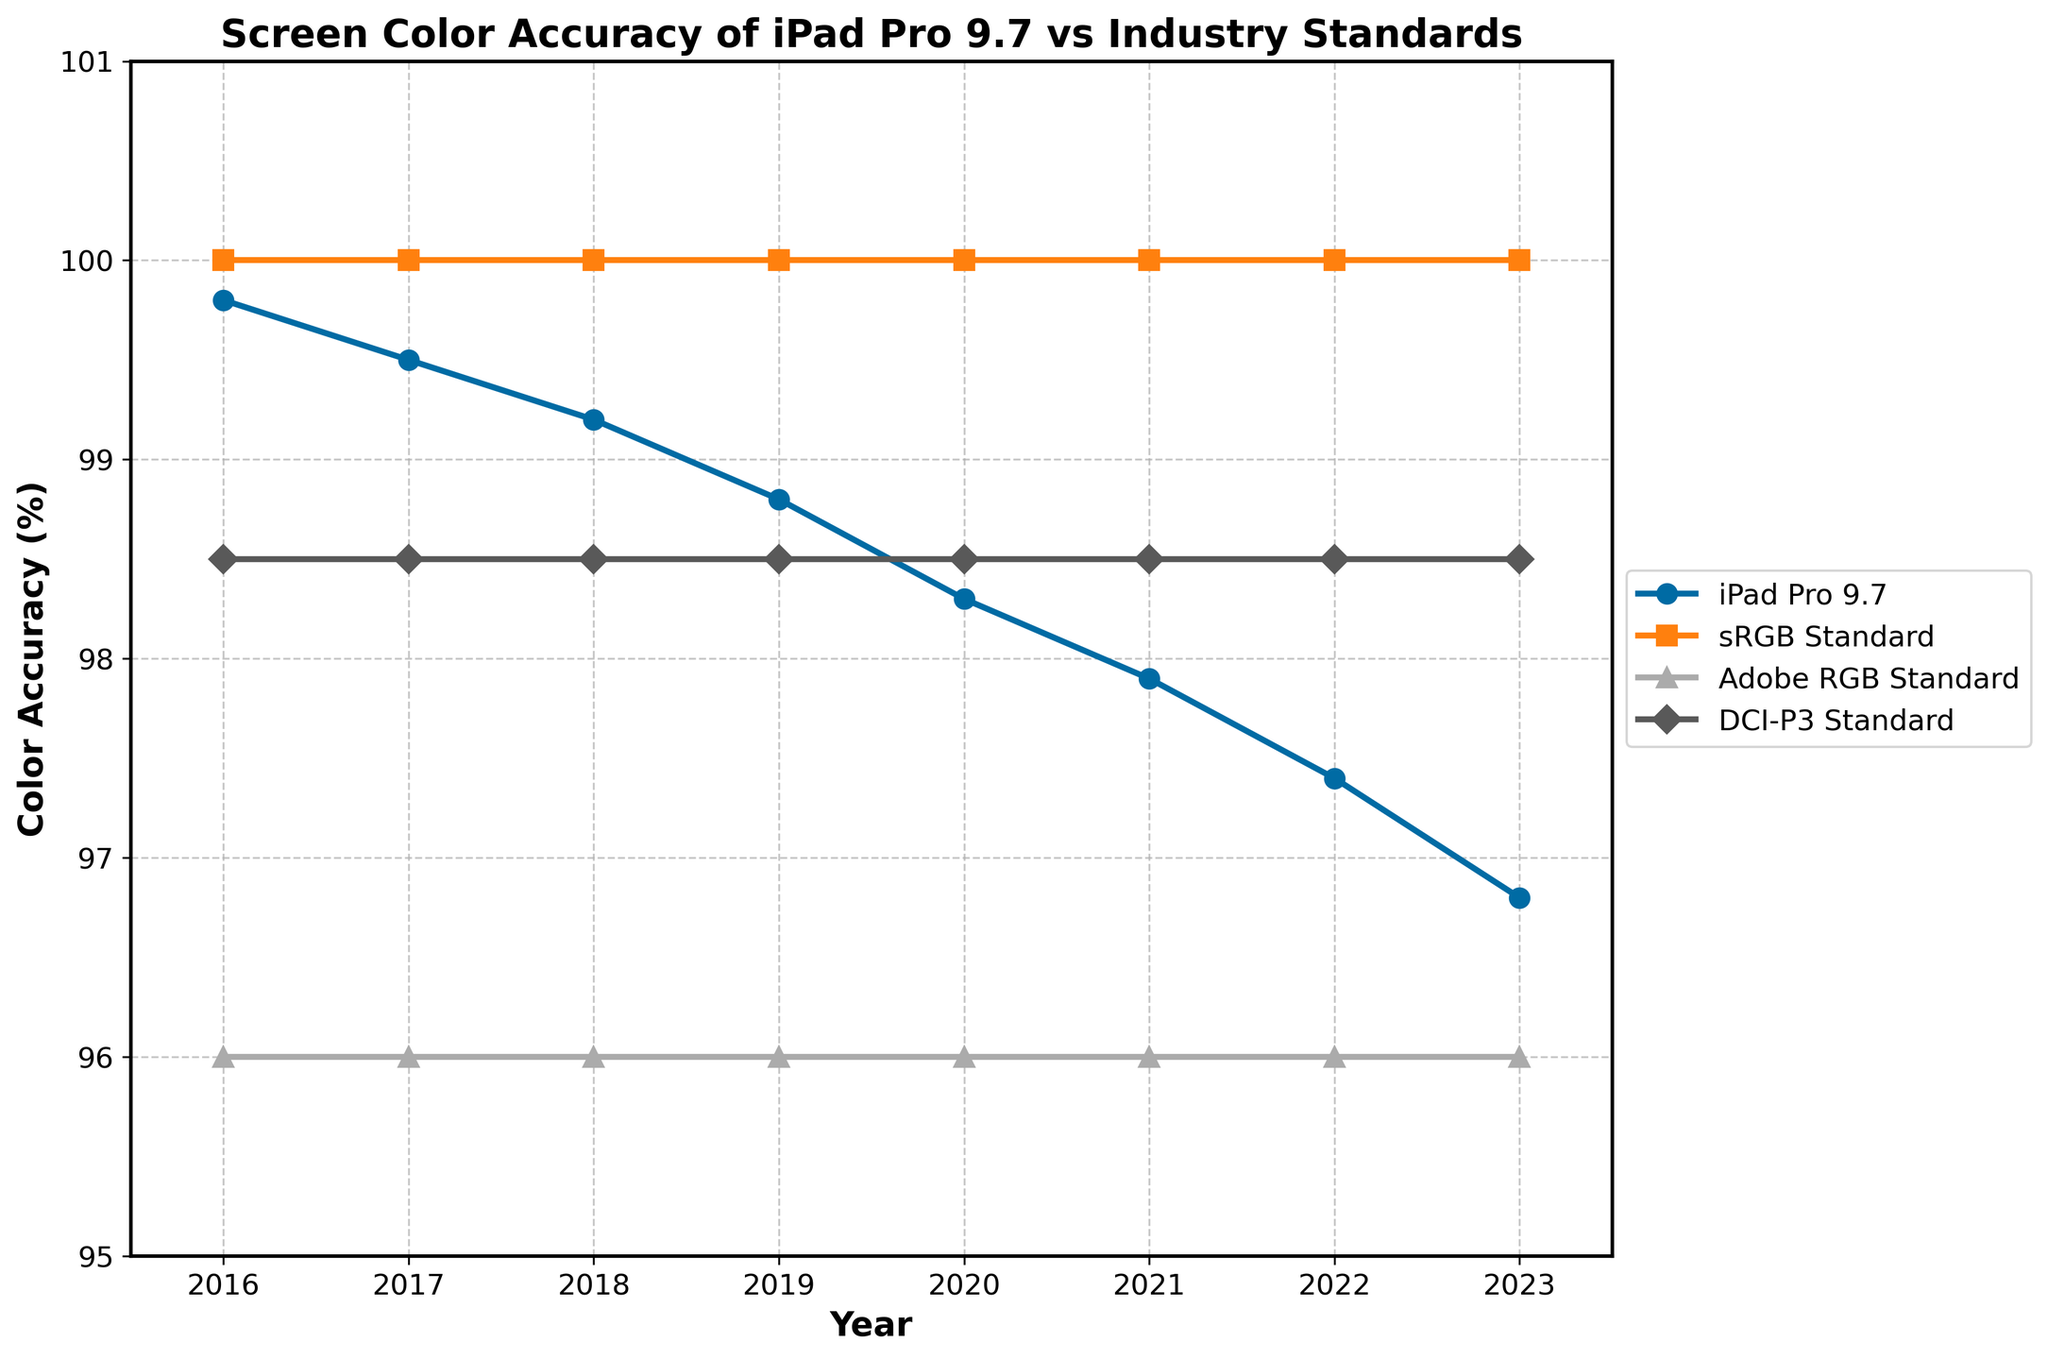What year did the iPad Pro 9.7 have the highest screen color accuracy in the provided data? To find the year with the highest screen color accuracy for the iPad Pro 9.7, we need to identify the highest value in the 'iPad Pro 9.7' series and note the corresponding year. The highest accuracy is 99.8% in 2016.
Answer: 2016 How does the iPad Pro 9.7's screen color accuracy in 2020 compare to the DCI-P3 standard in 2020? Compare the values for the iPad Pro 9.7 and the DCI-P3 standard in 2020. The values are 98.3% for the iPad Pro 9.7 and 98.5% for the DCI-P3 standard. The iPad Pro 9.7 has slightly lower accuracy.
Answer: Lower by 0.2% What is the average screen color accuracy of the iPad Pro 9.7 from 2016 to 2023? Calculate the sum of the iPad Pro 9.7 accuracy values from 2016 to 2023 (99.8 + 99.5 + 99.2 + 98.8 + 98.3 + 97.9 + 97.4 + 96.8) which equals 787.7, then divide by 8 (the number of years) to get the average: 787.7 / 8 = 98.4625%.
Answer: 98.46% In which year did the iPad Pro 9.7 first fall below 98% color accuracy? Inspect the data series for the iPad Pro 9.7 and locate the first year where the accuracy is below 98%. The accuracy first falls below 98% in 2021 (97.9%).
Answer: 2021 By how much did the screen color accuracy of the iPad Pro 9.7 decline from 2016 to 2023? Subtract the 2023 value from the 2016 value in the iPad Pro 9.7 series: 99.8% - 96.8% = 3%. The screen color accuracy declined by 3%.
Answer: 3% Which has the highest visual marker: the iPad Pro 9.7 in 2019 or the Adobe RGB Standard in the same year? Compare the visual markers: the iPad Pro 9.7 in 2019 (98.8%) and the Adobe RGB Standard in 2019 (96%). The iPad Pro 9.7 value is higher.
Answer: iPad Pro 9.7 in 2019 What is the trend of the screen color accuracy of the iPad Pro 9.7 over the years shown? Examine the values for the iPad Pro 9.7 from 2016 to 2023. The values consistently decrease from 99.8% to 96.8%, indicating a downward trend.
Answer: Downward trend How does the screen color accuracy of the iPad Pro 9.7 in 2023 compare to the other standards? Compare the 2023 iPad Pro 9.7 accuracy (96.8%) with the standards: sRGB (100%), Adobe RGB (96%), and DCI-P3 (98.5%). The iPad Pro 9.7 is below sRGB and DCI-P3 but higher than Adobe RGB.
Answer: Lower than sRGB and DCI-P3, higher than Adobe RGB If the screen color accuracy for the iPad Pro 9.7 continued to decline at the same rate beyond 2023, what would be the projected accuracy in 2024? Calculate the yearly decline from 2016 to 2023, which is (99.8 - 96.8) / (2023 - 2016) = 3 / 7 ≈ 0.4286%. Subtract this rate from the 2023 value: 96.8% - 0.4286% ≈ 96.3714%.
Answer: 96.37% Compare the color accuracies of the iPad Pro 9.7 and the sRGB Standard over their respective time periods and determine the difference. The iPad Pro 9.7 values (99.8, 99.5, 99.2, 98.8, 98.3, 97.9, 97.4, 96.8) have an average of 98.4625%. The sRGB values remain at 100% throughout the same period. The difference is 100% - 98.4625% = 1.5375%.
Answer: 1.54% 